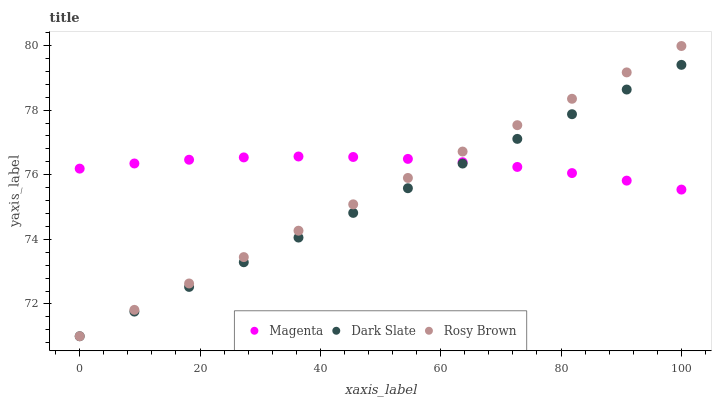Does Dark Slate have the minimum area under the curve?
Answer yes or no. Yes. Does Magenta have the maximum area under the curve?
Answer yes or no. Yes. Does Rosy Brown have the minimum area under the curve?
Answer yes or no. No. Does Rosy Brown have the maximum area under the curve?
Answer yes or no. No. Is Rosy Brown the smoothest?
Answer yes or no. Yes. Is Magenta the roughest?
Answer yes or no. Yes. Is Magenta the smoothest?
Answer yes or no. No. Is Rosy Brown the roughest?
Answer yes or no. No. Does Dark Slate have the lowest value?
Answer yes or no. Yes. Does Magenta have the lowest value?
Answer yes or no. No. Does Rosy Brown have the highest value?
Answer yes or no. Yes. Does Magenta have the highest value?
Answer yes or no. No. Does Magenta intersect Dark Slate?
Answer yes or no. Yes. Is Magenta less than Dark Slate?
Answer yes or no. No. Is Magenta greater than Dark Slate?
Answer yes or no. No. 